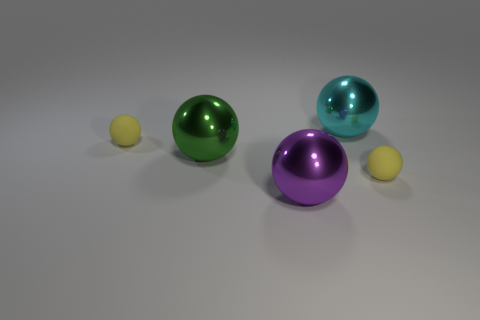Subtract all green balls. How many balls are left? 4 Subtract 2 spheres. How many spheres are left? 3 Subtract all blue spheres. Subtract all gray cylinders. How many spheres are left? 5 Add 3 metal things. How many objects exist? 8 Add 3 small things. How many small things are left? 5 Add 2 large purple objects. How many large purple objects exist? 3 Subtract 0 red blocks. How many objects are left? 5 Subtract all big gray blocks. Subtract all large green metallic things. How many objects are left? 4 